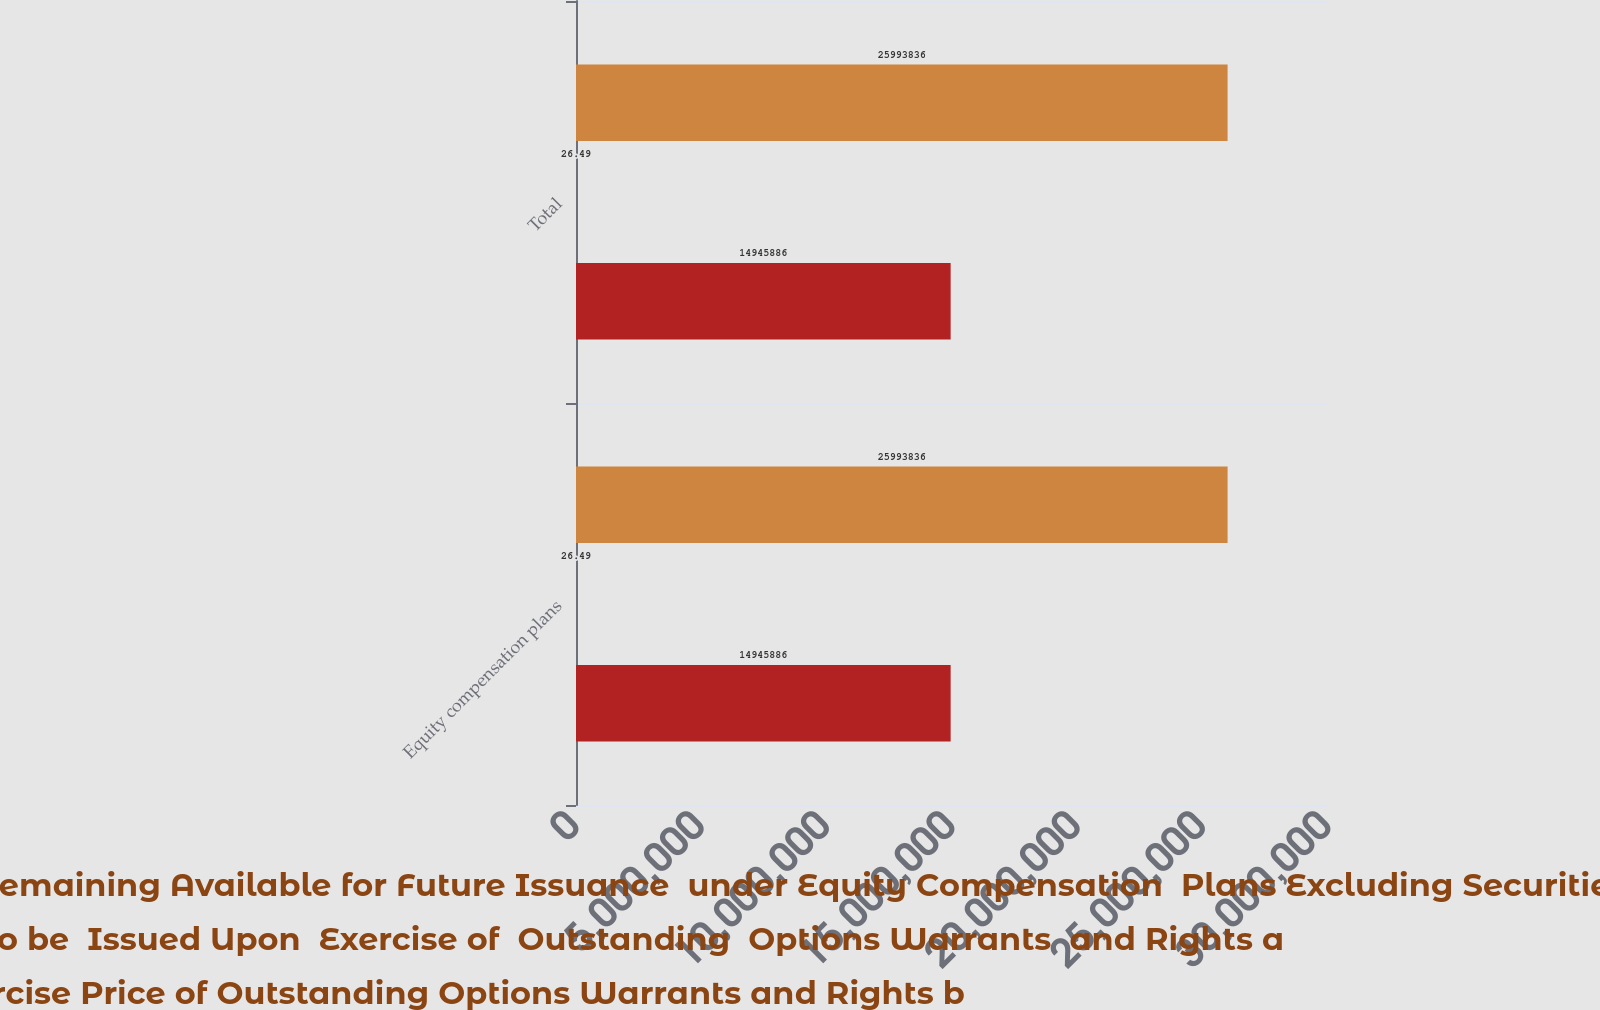Convert chart to OTSL. <chart><loc_0><loc_0><loc_500><loc_500><stacked_bar_chart><ecel><fcel>Equity compensation plans<fcel>Total<nl><fcel>Number of Securities Remaining Available for Future Issuance  under Equity Compensation  Plans Excluding Securities Reflected in Column a c<fcel>2.59938e+07<fcel>2.59938e+07<nl><fcel>Number of  Securities to be  Issued Upon  Exercise of  Outstanding  Options Warrants  and Rights a<fcel>26.49<fcel>26.49<nl><fcel>WeightedAverage Exercise Price of Outstanding Options Warrants and Rights b<fcel>1.49459e+07<fcel>1.49459e+07<nl></chart> 